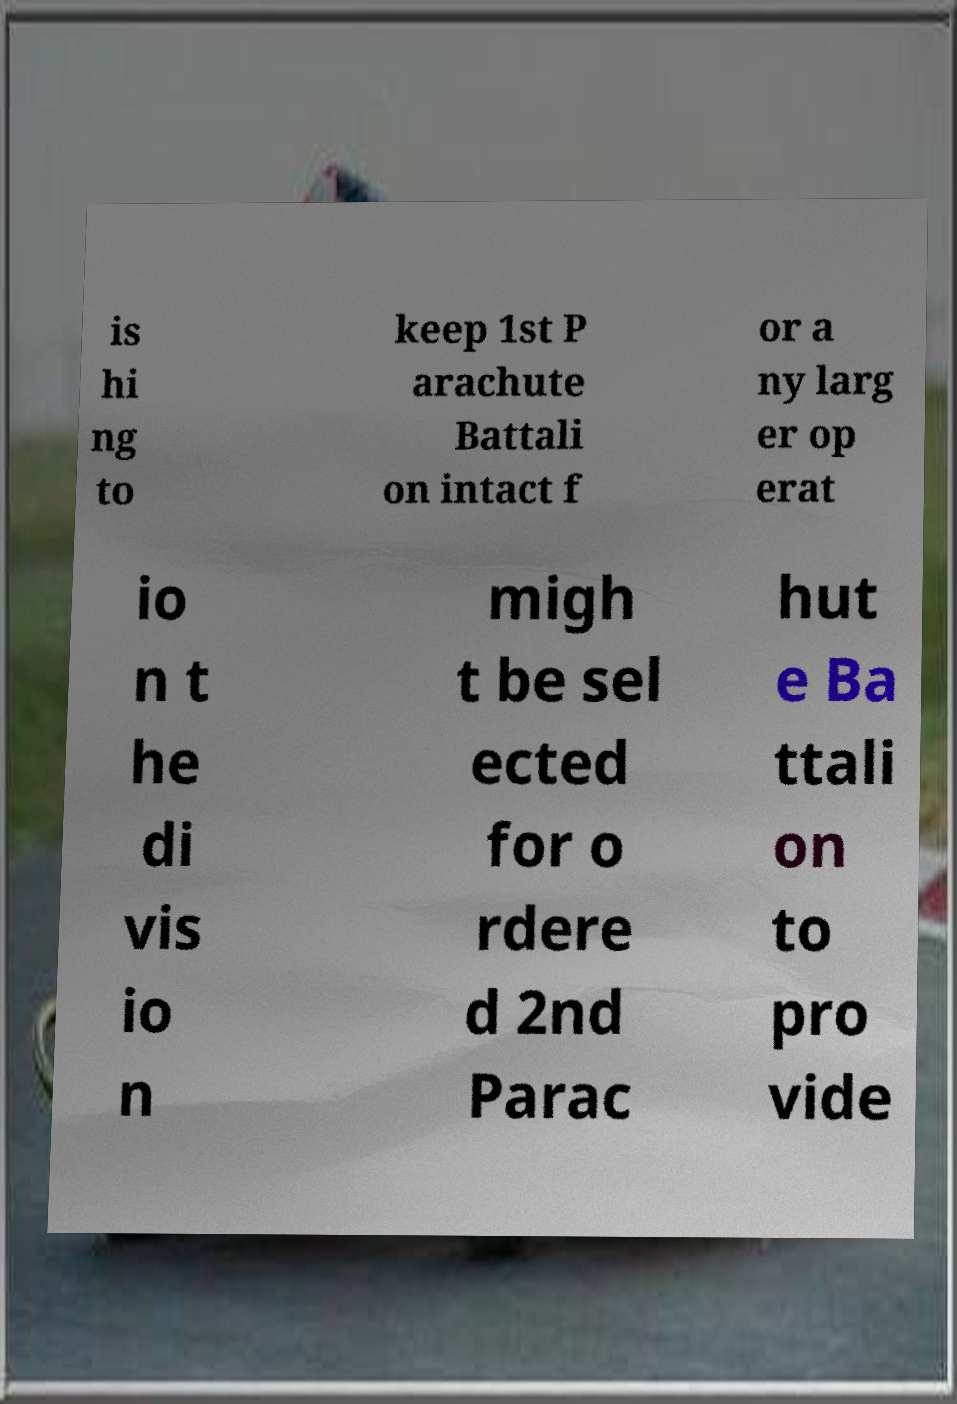There's text embedded in this image that I need extracted. Can you transcribe it verbatim? is hi ng to keep 1st P arachute Battali on intact f or a ny larg er op erat io n t he di vis io n migh t be sel ected for o rdere d 2nd Parac hut e Ba ttali on to pro vide 